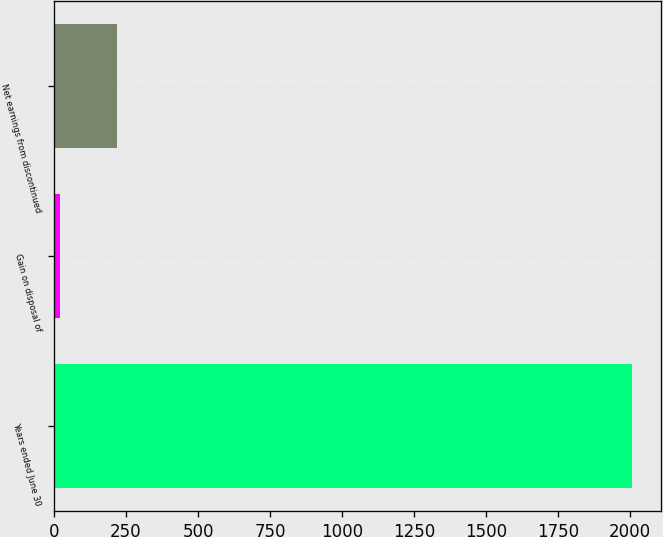Convert chart. <chart><loc_0><loc_0><loc_500><loc_500><bar_chart><fcel>Years ended June 30<fcel>Gain on disposal of<fcel>Net earnings from discontinued<nl><fcel>2007<fcel>20.9<fcel>219.51<nl></chart> 